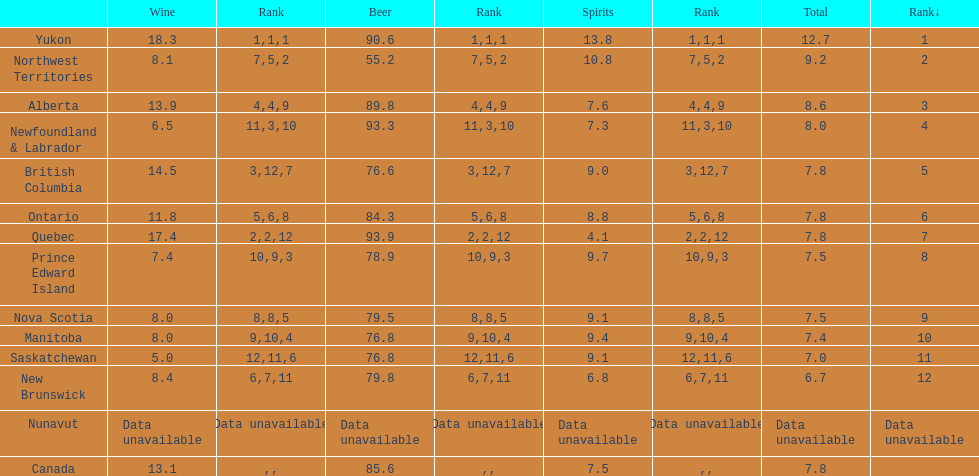Between quebec and northwest territories, which one had a higher beer consumption? Quebec. 